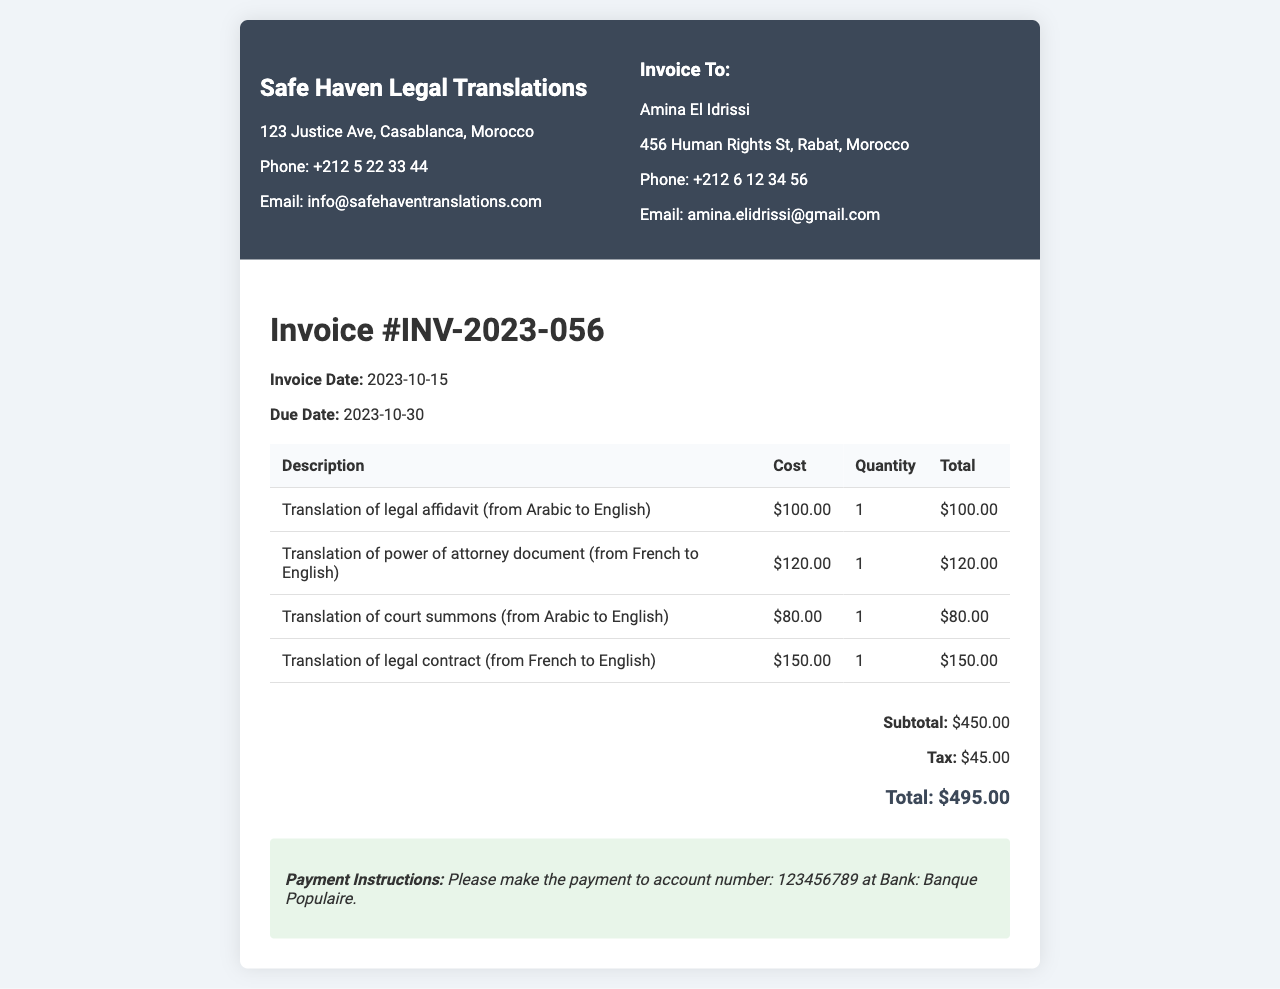What is the invoice number? The invoice number is a unique identifier for the bill, listed as #INV-2023-056.
Answer: #INV-2023-056 What is the due date for this invoice? The due date indicates when the payment is expected, which is stated as 2023-10-30.
Answer: 2023-10-30 How much is the subtotal of the invoice? The subtotal is the total before tax, provided as $450.00.
Answer: $450.00 What is the total amount due? The total amount due is the final amount after tax, which is noted as $495.00.
Answer: $495.00 How many documents were translated? The quantity of documents is reflected in the total number of line items, which is 4.
Answer: 4 What is the cost of translating the court summons? The specific cost for the translation of the court summons is mentioned as $80.00.
Answer: $80.00 Who is the client for this invoice? The client’s name is listed at the top of the invoice as Amina El Idrissi.
Answer: Amina El Idrissi What are the payment instructions provided? The payment instructions detail where to make the payment, specifically to account number 123456789 at Banque Populaire.
Answer: account number: 123456789 at Bank: Banque Populaire What is the tax amount applied to the invoice? The tax amount is clearly stated as $45.00, added to the subtotal.
Answer: $45.00 